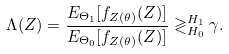<formula> <loc_0><loc_0><loc_500><loc_500>\Lambda ( Z ) = \frac { E _ { \Theta _ { 1 } } [ f _ { Z ( \theta ) } ( Z ) ] } { E _ { \Theta _ { 0 } } [ f _ { Z ( \theta ) } ( Z ) ] } \gtrless _ { H _ { 0 } } ^ { H _ { 1 } } \gamma .</formula> 